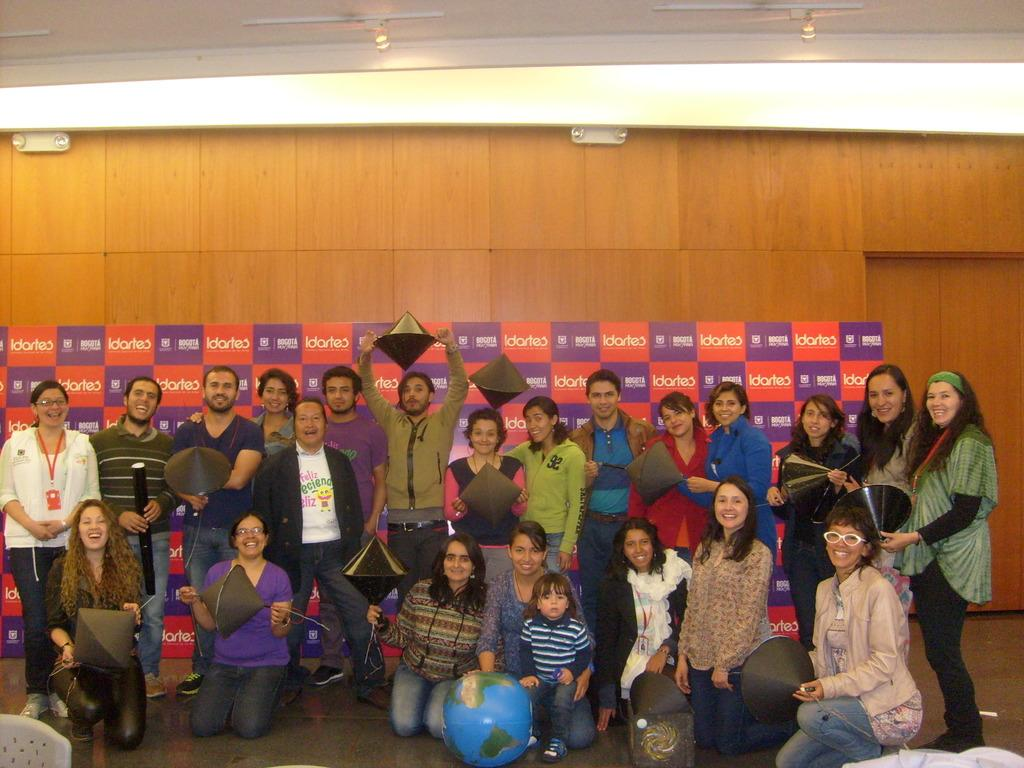Who or what can be seen in the image? There are people in the image. What are the people doing in the image? The people are holding objects in their hands. What additional information can be gathered from the image? There is a banner with text in the image. What is the position of the governor in the image? There is no governor present in the image, so it is not possible to determine their position. 